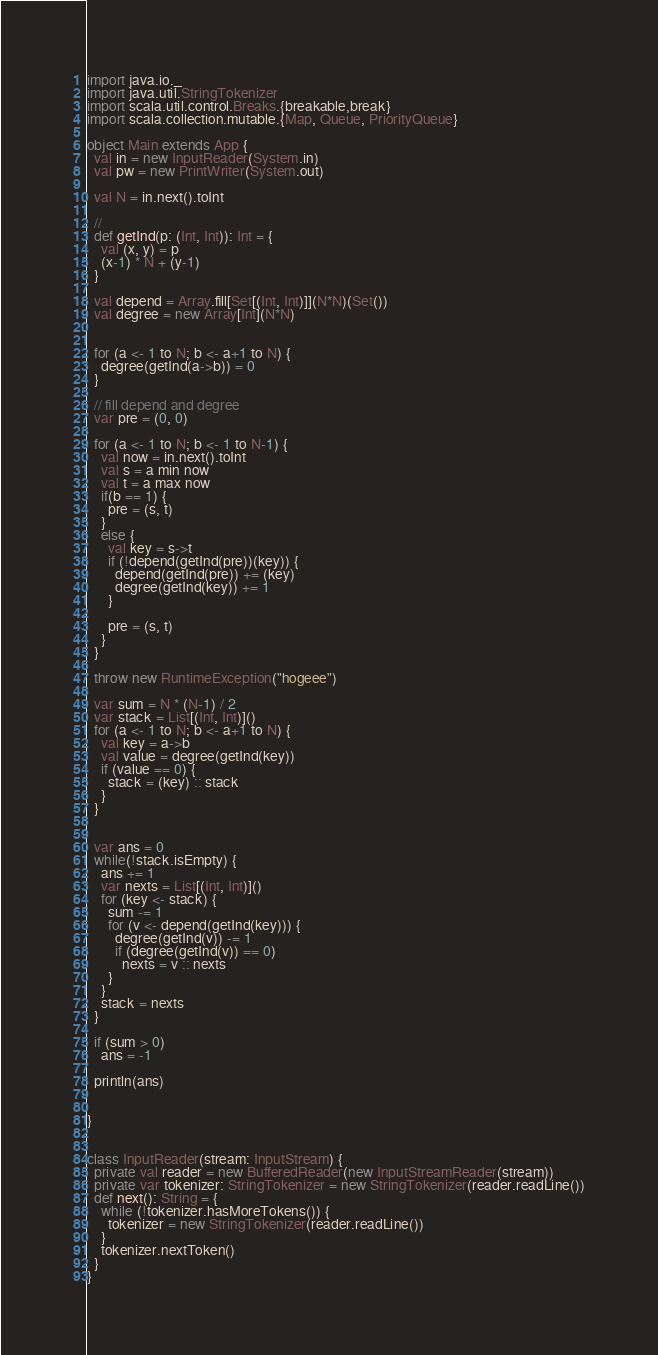<code> <loc_0><loc_0><loc_500><loc_500><_Scala_>import java.io._
import java.util.StringTokenizer
import scala.util.control.Breaks.{breakable,break}
import scala.collection.mutable.{Map, Queue, PriorityQueue}

object Main extends App {
  val in = new InputReader(System.in)
  val pw = new PrintWriter(System.out)

  val N = in.next().toInt

  //
  def getInd(p: (Int, Int)): Int = {
    val (x, y) = p
    (x-1) * N + (y-1)
  }

  val depend = Array.fill[Set[(Int, Int)]](N*N)(Set())
  val degree = new Array[Int](N*N)

  
  for (a <- 1 to N; b <- a+1 to N) {
    degree(getInd(a->b)) = 0
  }

  // fill depend and degree
  var pre = (0, 0)

  for (a <- 1 to N; b <- 1 to N-1) {
    val now = in.next().toInt
    val s = a min now
    val t = a max now
    if(b == 1) {
      pre = (s, t)
    }
    else {
      val key = s->t
      if (!depend(getInd(pre))(key)) {
        depend(getInd(pre)) += (key)
        degree(getInd(key)) += 1
      }

      pre = (s, t)
    }
  }

  throw new RuntimeException("hogeee")

  var sum = N * (N-1) / 2
  var stack = List[(Int, Int)]()
  for (a <- 1 to N; b <- a+1 to N) {
    val key = a->b
    val value = degree(getInd(key))
    if (value == 0) {
      stack = (key) :: stack
    }
  }


  var ans = 0
  while(!stack.isEmpty) {
    ans += 1
    var nexts = List[(Int, Int)]()
    for (key <- stack) {
      sum -= 1
      for (v <- depend(getInd(key))) {
        degree(getInd(v)) -= 1
        if (degree(getInd(v)) == 0)
          nexts = v :: nexts
      }
    }
    stack = nexts
  }

  if (sum > 0)
    ans = -1

  println(ans)


}


class InputReader(stream: InputStream) {
  private val reader = new BufferedReader(new InputStreamReader(stream))
  private var tokenizer: StringTokenizer = new StringTokenizer(reader.readLine())
  def next(): String = {
    while (!tokenizer.hasMoreTokens()) {
      tokenizer = new StringTokenizer(reader.readLine())
    }
    tokenizer.nextToken()
  }
}
</code> 